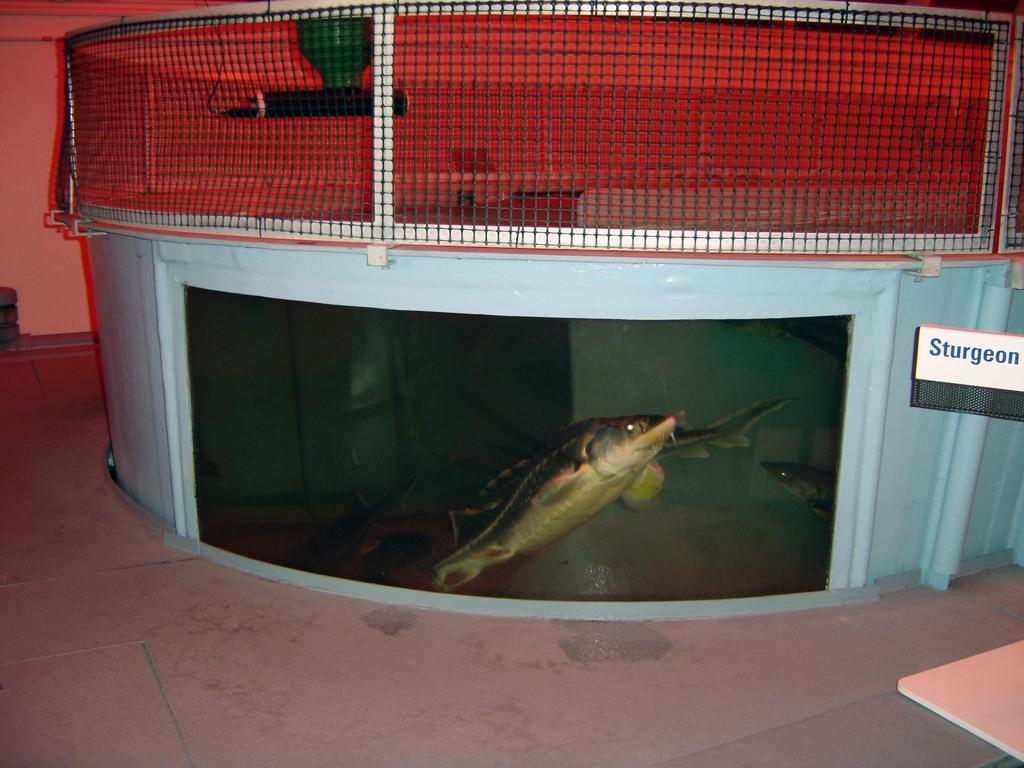What type of animals can be seen in the image? There are fishes in water in the image. Where are the fishes located? The fishes are in a container filled with water. What is visible in the background of the image? There is a sign board with text and a mesh in the background of the image. Can you tell me how many goats are present in the image? There are no goats present in the image; it features fishes in water. What role does the father play in the image? There is no reference to a father or any human figures in the image. 